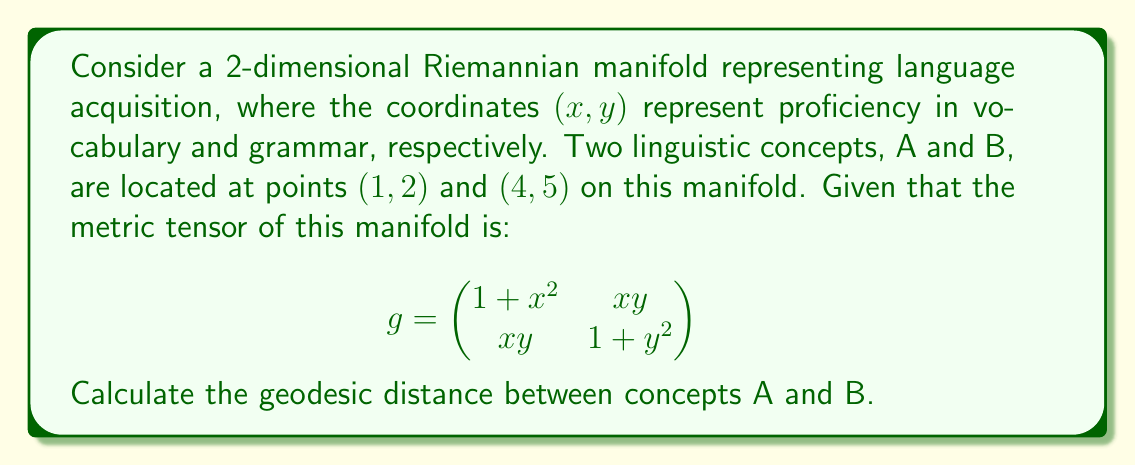Provide a solution to this math problem. To calculate the geodesic distance between two points on a Riemannian manifold, we need to follow these steps:

1) First, we need to parameterize the curve connecting the two points. Let's use $t$ as our parameter, with $t \in [0, 1]$. We can represent the curve as:

   $x(t) = 1 + 3t$
   $y(t) = 2 + 3t$

2) The formula for the length of a curve on a Riemannian manifold is:

   $$L = \int_0^1 \sqrt{g_{ij} \frac{dx^i}{dt} \frac{dx^j}{dt}} dt$$

3) We need to calculate $\frac{dx}{dt}$ and $\frac{dy}{dt}$:

   $\frac{dx}{dt} = 3$
   $\frac{dy}{dt} = 3$

4) Now, let's substitute these into our length formula:

   $$L = \int_0^1 \sqrt{g_{11}(\frac{dx}{dt})^2 + 2g_{12}\frac{dx}{dt}\frac{dy}{dt} + g_{22}(\frac{dy}{dt})^2} dt$$

5) Substituting the metric tensor components:

   $$L = \int_0^1 \sqrt{(1+(1+3t)^2)(3^2) + 2(1+3t)(2+3t)(3)(3) + (1+(2+3t)^2)(3^2)} dt$$

6) Simplifying:

   $$L = 3\int_0^1 \sqrt{(10+18t+9t^2) + 2(2+9t+9t^2) + (13+18t+9t^2)} dt$$
   $$L = 3\int_0^1 \sqrt{25+45t+27t^2} dt$$

7) This integral doesn't have a simple closed-form solution. We need to use numerical integration techniques to evaluate it. Using a computational tool, we find:

   $$L \approx 11.7851$$

This represents the geodesic distance between the two linguistic concepts on our language acquisition manifold.
Answer: $11.7851$ (units of linguistic distance) 